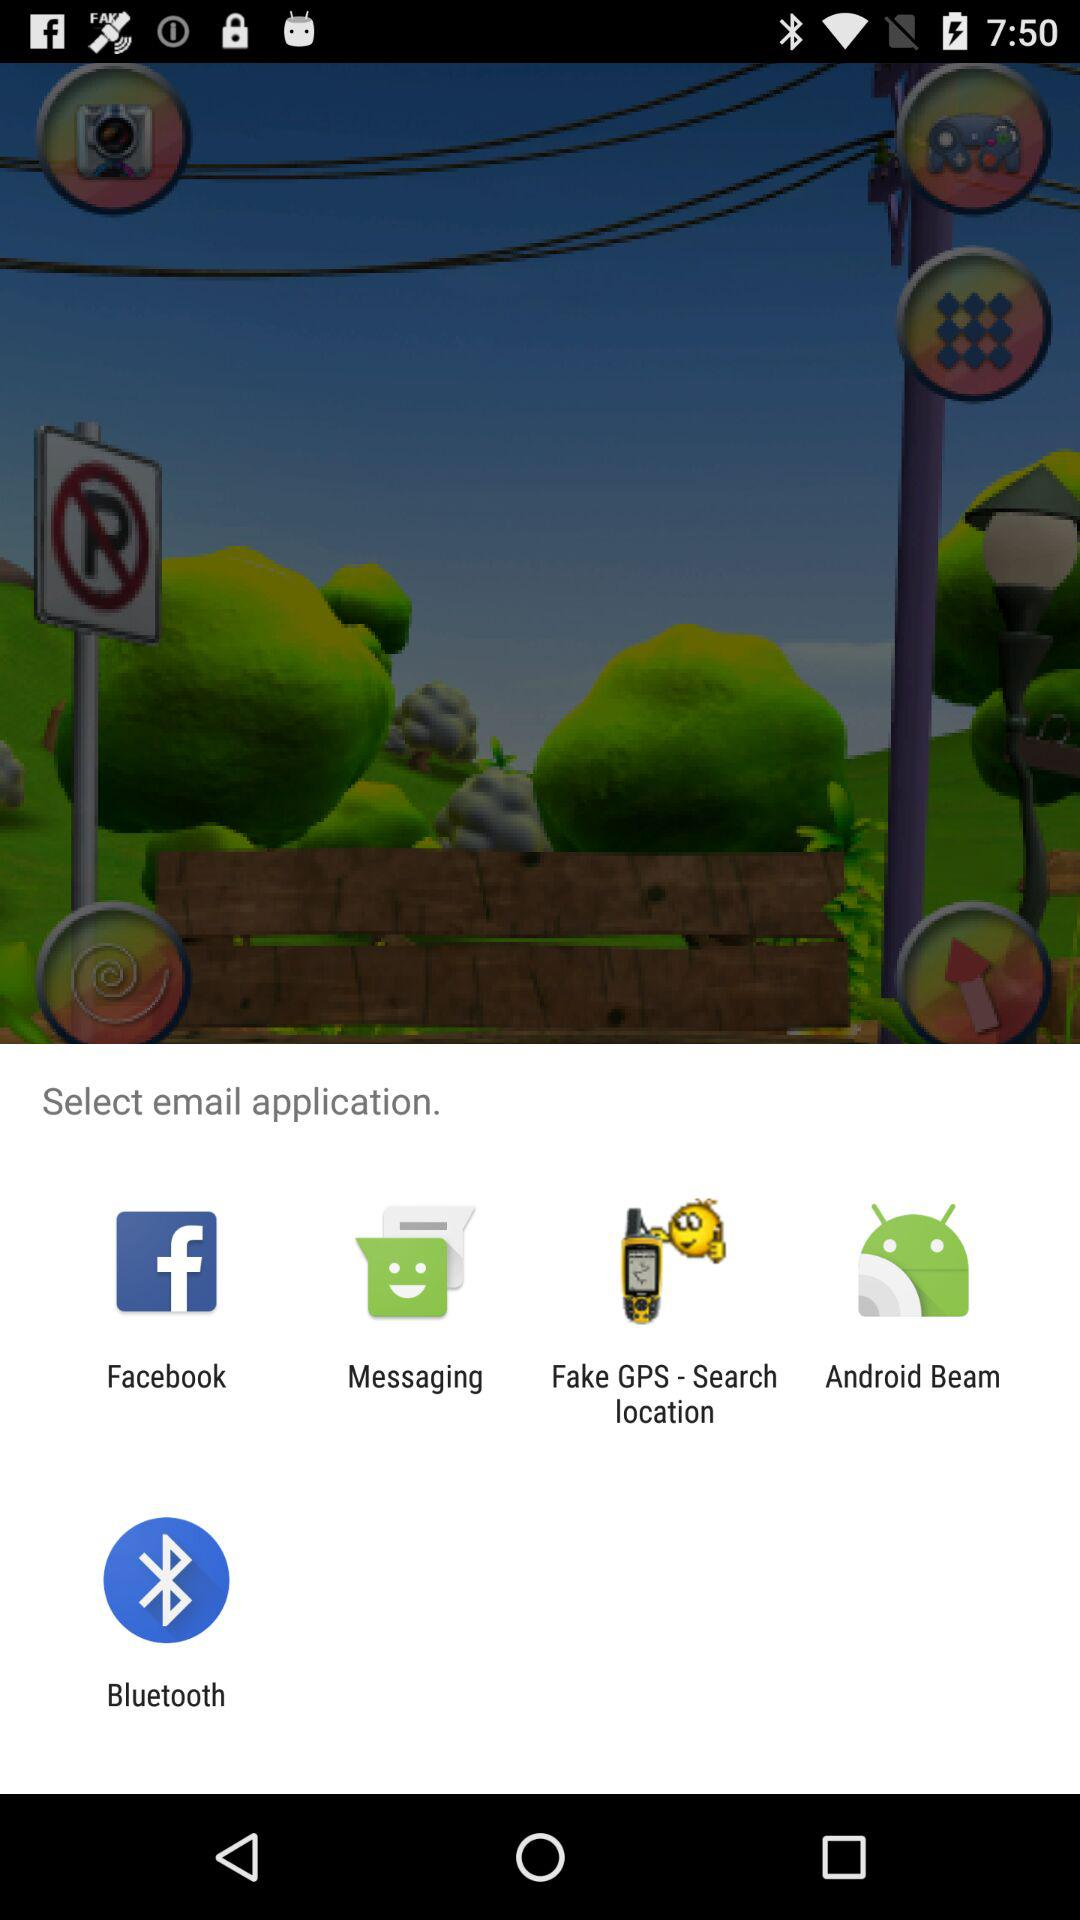What applications can be used to select email application? The applications are "Facebook", "Messaging", "Fake GPS - Search location", "Android Beam" and "Bluetooth". 